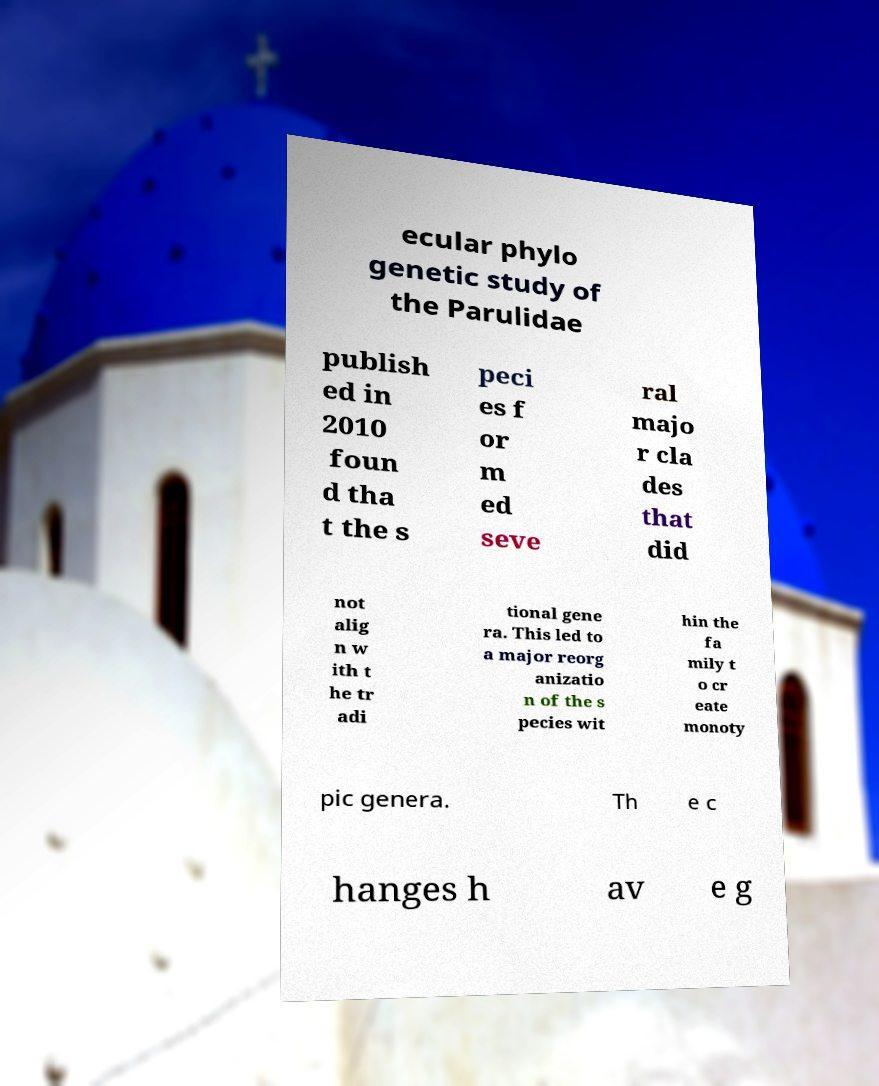Could you extract and type out the text from this image? ecular phylo genetic study of the Parulidae publish ed in 2010 foun d tha t the s peci es f or m ed seve ral majo r cla des that did not alig n w ith t he tr adi tional gene ra. This led to a major reorg anizatio n of the s pecies wit hin the fa mily t o cr eate monoty pic genera. Th e c hanges h av e g 